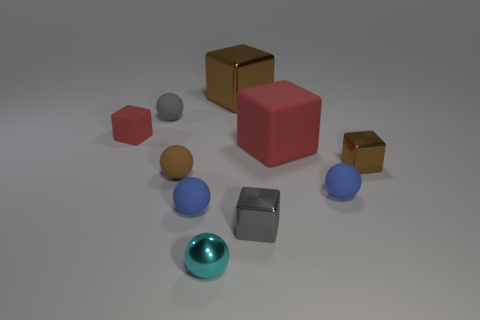Is the number of large metal objects that are left of the cyan ball greater than the number of spheres that are on the left side of the big red rubber object?
Give a very brief answer. No. Is the color of the small metallic ball the same as the block that is behind the gray sphere?
Provide a short and direct response. No. There is a gray cube that is the same size as the cyan metal object; what material is it?
Your answer should be very brief. Metal. What number of objects are tiny shiny blocks or shiny things to the right of the shiny sphere?
Provide a succinct answer. 3. There is a brown rubber ball; does it have the same size as the red cube that is to the right of the small gray sphere?
Keep it short and to the point. No. What number of cubes are small brown matte objects or red things?
Offer a very short reply. 2. How many cubes are both behind the gray rubber thing and in front of the big rubber object?
Your answer should be very brief. 0. What number of other things are the same color as the large metal cube?
Ensure brevity in your answer.  2. There is a brown metallic thing behind the tiny gray sphere; what is its shape?
Provide a short and direct response. Cube. Is the material of the big red block the same as the tiny brown block?
Your answer should be compact. No. 